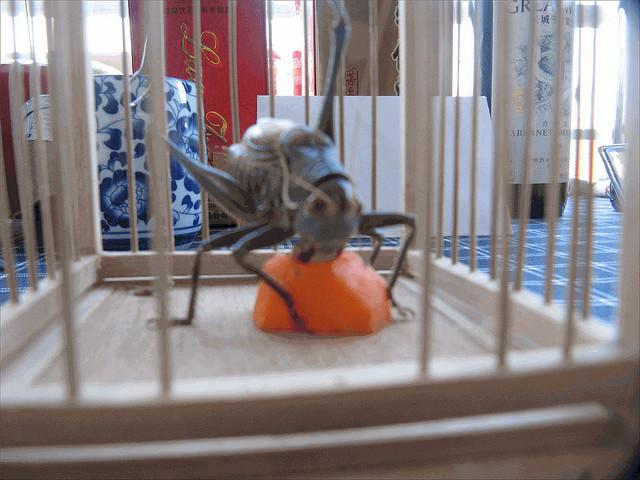What kind of animal do you see in the picture?

Choices:
A) insect
B) fish
C) mammal
D) reptile insect 